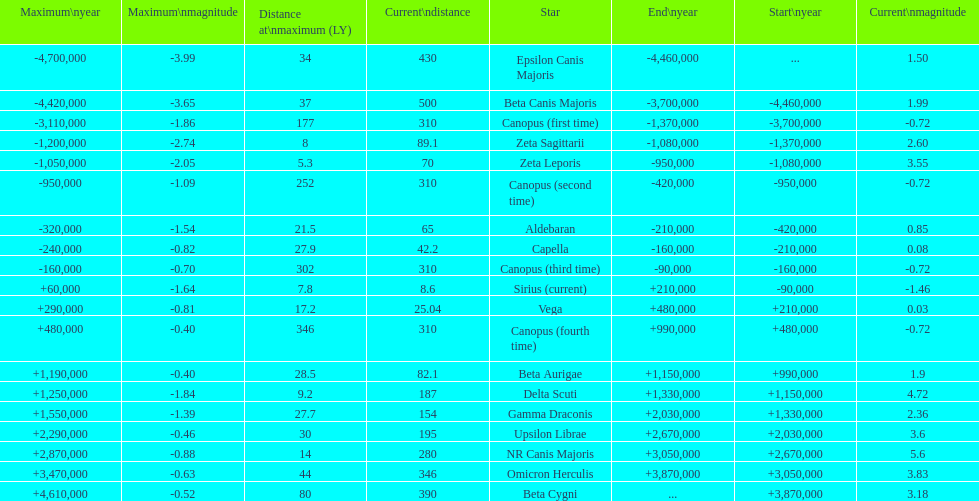What is the number of stars that have a maximum magnitude less than zero? 5. Parse the full table. {'header': ['Maximum\\nyear', 'Maximum\\nmagnitude', 'Distance at\\nmaximum (LY)', 'Current\\ndistance', 'Star', 'End\\nyear', 'Start\\nyear', 'Current\\nmagnitude'], 'rows': [['-4,700,000', '-3.99', '34', '430', 'Epsilon Canis Majoris', '-4,460,000', '...', '1.50'], ['-4,420,000', '-3.65', '37', '500', 'Beta Canis Majoris', '-3,700,000', '-4,460,000', '1.99'], ['-3,110,000', '-1.86', '177', '310', 'Canopus (first time)', '-1,370,000', '-3,700,000', '-0.72'], ['-1,200,000', '-2.74', '8', '89.1', 'Zeta Sagittarii', '-1,080,000', '-1,370,000', '2.60'], ['-1,050,000', '-2.05', '5.3', '70', 'Zeta Leporis', '-950,000', '-1,080,000', '3.55'], ['-950,000', '-1.09', '252', '310', 'Canopus (second time)', '-420,000', '-950,000', '-0.72'], ['-320,000', '-1.54', '21.5', '65', 'Aldebaran', '-210,000', '-420,000', '0.85'], ['-240,000', '-0.82', '27.9', '42.2', 'Capella', '-160,000', '-210,000', '0.08'], ['-160,000', '-0.70', '302', '310', 'Canopus (third time)', '-90,000', '-160,000', '-0.72'], ['+60,000', '-1.64', '7.8', '8.6', 'Sirius (current)', '+210,000', '-90,000', '-1.46'], ['+290,000', '-0.81', '17.2', '25.04', 'Vega', '+480,000', '+210,000', '0.03'], ['+480,000', '-0.40', '346', '310', 'Canopus (fourth time)', '+990,000', '+480,000', '-0.72'], ['+1,190,000', '-0.40', '28.5', '82.1', 'Beta Aurigae', '+1,150,000', '+990,000', '1.9'], ['+1,250,000', '-1.84', '9.2', '187', 'Delta Scuti', '+1,330,000', '+1,150,000', '4.72'], ['+1,550,000', '-1.39', '27.7', '154', 'Gamma Draconis', '+2,030,000', '+1,330,000', '2.36'], ['+2,290,000', '-0.46', '30', '195', 'Upsilon Librae', '+2,670,000', '+2,030,000', '3.6'], ['+2,870,000', '-0.88', '14', '280', 'NR Canis Majoris', '+3,050,000', '+2,670,000', '5.6'], ['+3,470,000', '-0.63', '44', '346', 'Omicron Herculis', '+3,870,000', '+3,050,000', '3.83'], ['+4,610,000', '-0.52', '80', '390', 'Beta Cygni', '...', '+3,870,000', '3.18']]} 